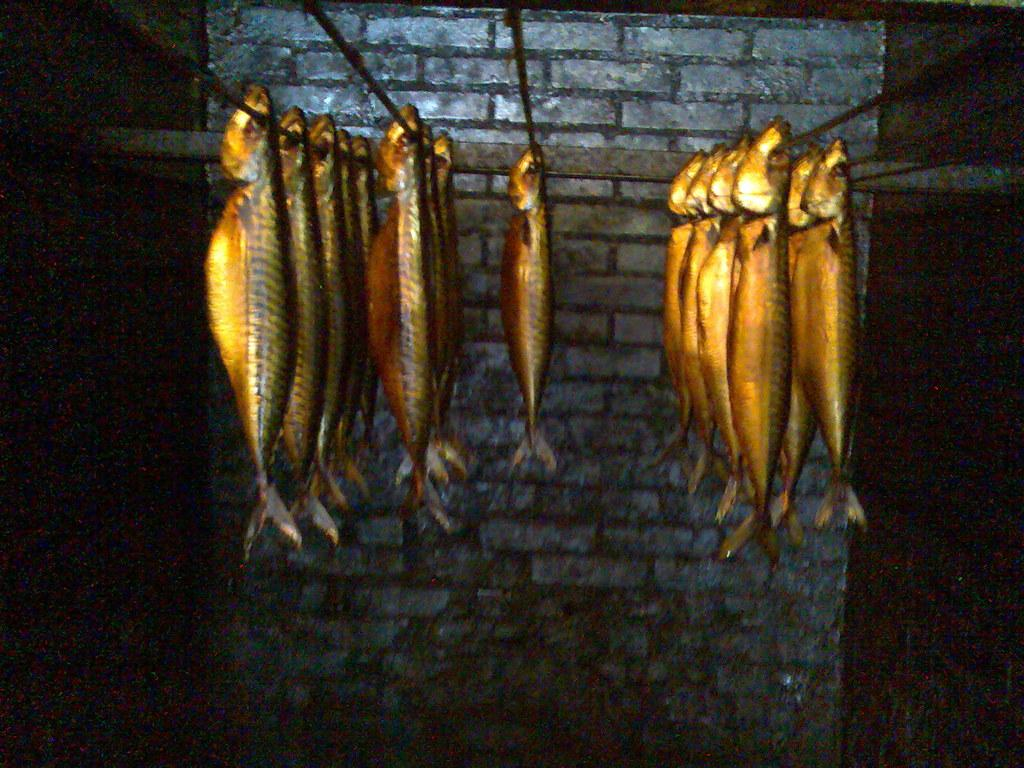What is the main subject of the image? The main subject of the image is fishes. What objects are related to the fishes in the image? There are rods present in the image. What can be seen in the background of the image? There is a wall in the background of the image. What type of development can be seen taking place near the fishes in the image? There is no development or construction activity visible in the image; it primarily features fishes and rods. 